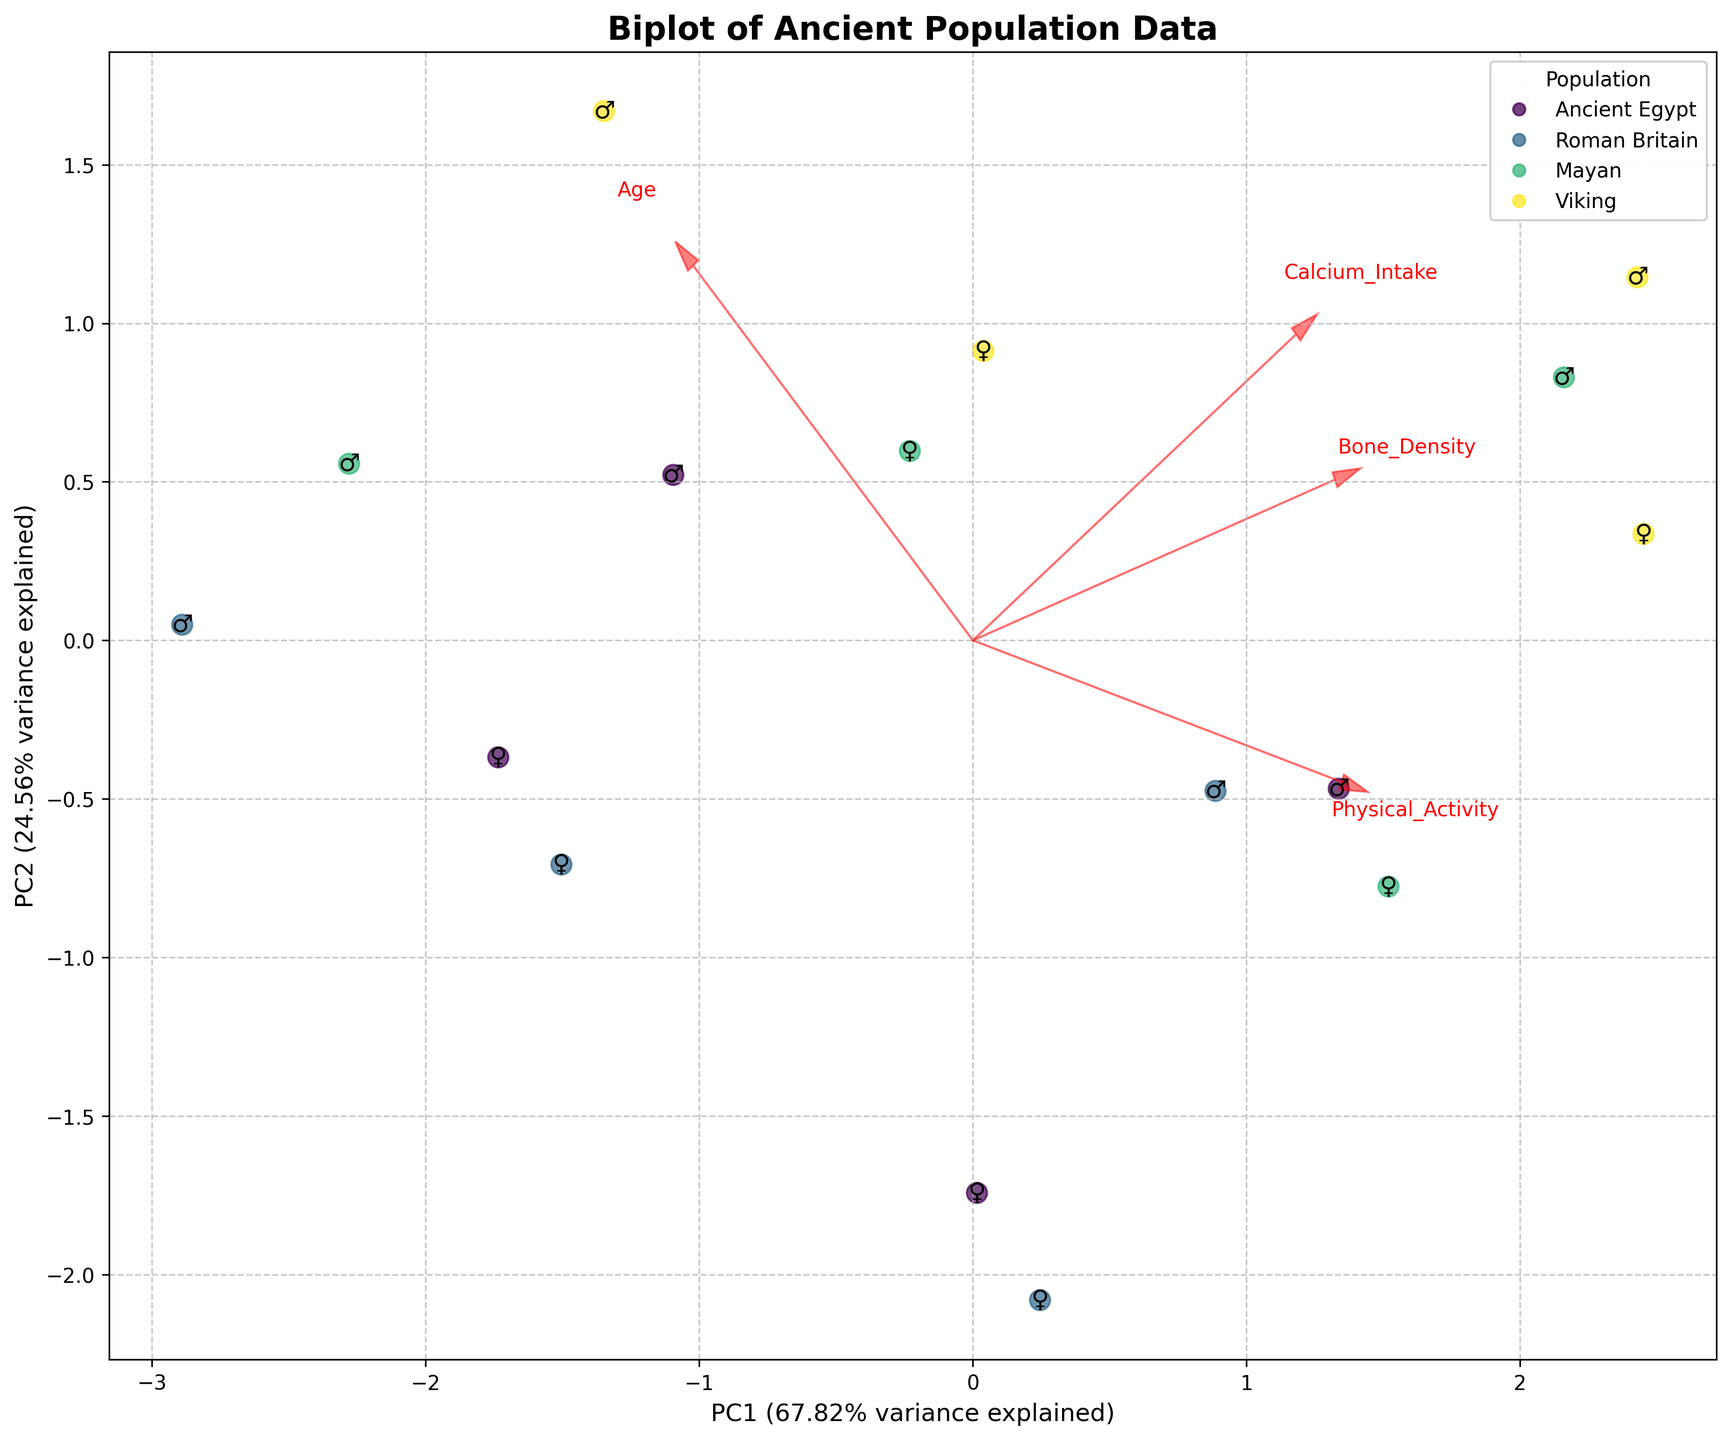What populations are included in the biplot? The populations can be identified by the color-coded legend on the biplot. These include Ancient Egypt, Roman Britain, Mayan, and Viking.
Answer: Ancient Egypt, Roman Britain, Mayan, Viking Which gender markers are used to represent males and females in the biplot? The biplot uses gender symbols to represent males and females. Males are marked with ♂ and females with ♀. This is evident by the symbols placed next to the data points on the plot.
Answer: ♂ for males, ♀ for females What is the primary relationship depicted on the horizontal axis of the biplot? The horizontal axis represents the first Principal Component (PC1), which shows the primary direction of data variance. The label indicates that PC1 explains a certain percentage of variance.
Answer: Principal Component 1 (PC1) What aspect of bone density is being analyzed in conjunction with age? The biplot includes vectors that represent bone density, calcium intake, and physical activity. The bone density is one of the factors influencing the placement of data points according to PC1 and PC2.
Answer: Bone density Which population shows a higher tendency for high calcium intake? By looking at the direction and length of the calcium intake vector in the biplot, the Viking population shows a higher tendency for high calcium intake, as many Viking data points are aligned closely in that direction.
Answer: Viking How does physical activity relate to bone density in the different populations? The biplot allows observing the direction of the physical activity vector in relation to bone density. Populations with higher physical activity levels, such as Roman Britain and Viking, also show higher bone density, indicated by the closeness of their data points to the bone density vector.
Answer: Higher physical activity relates to higher bone density Which gender appears to have greater bone density within each population? By observing the gender symbols and their placement on the biplot relative to bone density, males generally appear to have greater bone density across the different populations.
Answer: Males Are there any trends in bone density with increasing age? The direction and spread of the data points across PC1 and PC2 can give insights into trends with increasing age. In general, there is a noticeable trend of decreasing bone density with age, as older individuals, marked with upper age values, are positioned further from the bone density vector.
Answer: Decreasing bone density with age Which feature vector has the largest influence on PC1? This can be determined by the length and direction of the feature vectors on PC1. The Calcium Intake vector seems to have the largest influence on PC1 given its length in the horizontal direction.
Answer: Calcium Intake 